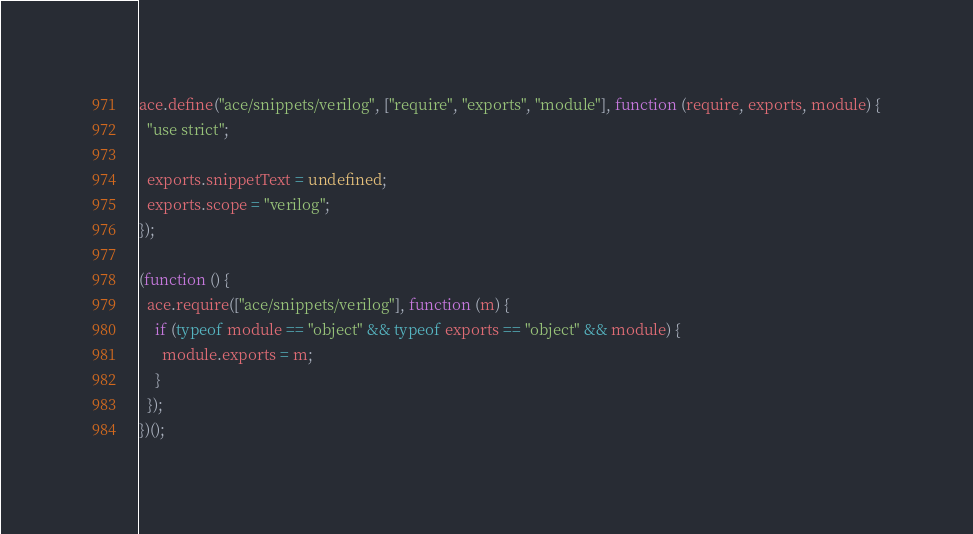Convert code to text. <code><loc_0><loc_0><loc_500><loc_500><_JavaScript_>ace.define("ace/snippets/verilog", ["require", "exports", "module"], function (require, exports, module) {
  "use strict";

  exports.snippetText = undefined;
  exports.scope = "verilog";
});

(function () {
  ace.require(["ace/snippets/verilog"], function (m) {
    if (typeof module == "object" && typeof exports == "object" && module) {
      module.exports = m;
    }
  });
})();</code> 